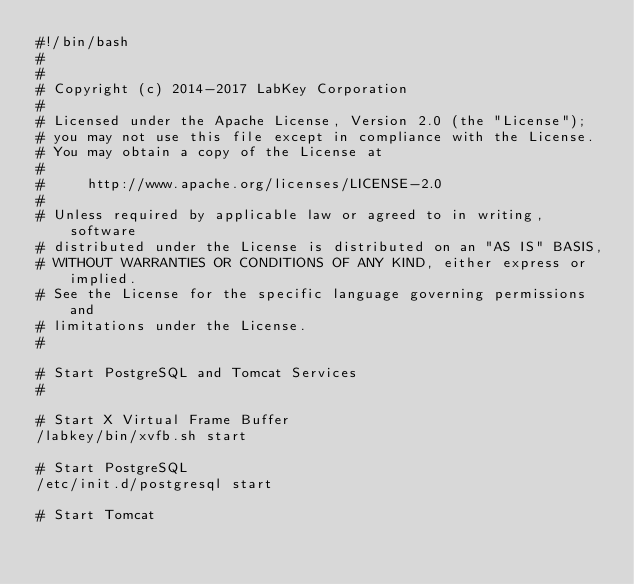Convert code to text. <code><loc_0><loc_0><loc_500><loc_500><_Bash_>#!/bin/bash
# 
#
# Copyright (c) 2014-2017 LabKey Corporation
#
# Licensed under the Apache License, Version 2.0 (the "License");
# you may not use this file except in compliance with the License.
# You may obtain a copy of the License at
#
#     http://www.apache.org/licenses/LICENSE-2.0
#
# Unless required by applicable law or agreed to in writing, software
# distributed under the License is distributed on an "AS IS" BASIS,
# WITHOUT WARRANTIES OR CONDITIONS OF ANY KIND, either express or implied.
# See the License for the specific language governing permissions and
# limitations under the License.
#

# Start PostgreSQL and Tomcat Services 
# 

# Start X Virtual Frame Buffer 
/labkey/bin/xvfb.sh start

# Start PostgreSQL
/etc/init.d/postgresql start 

# Start Tomcat </code> 